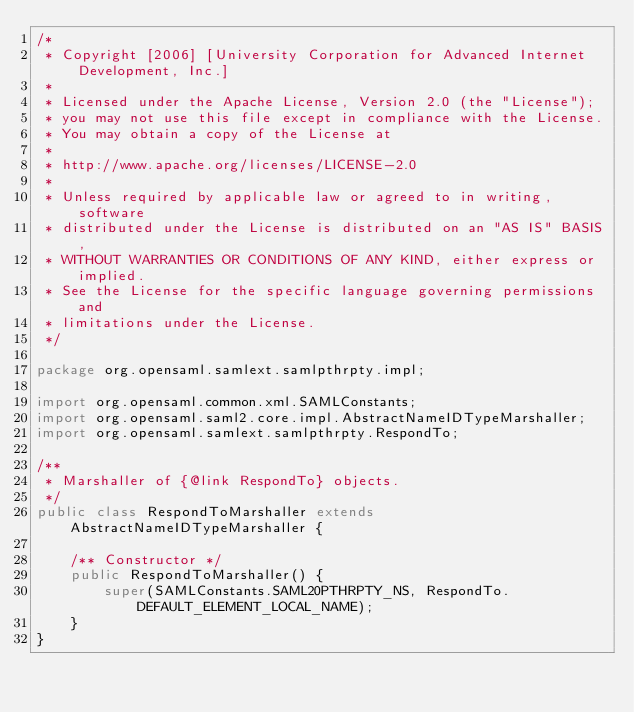Convert code to text. <code><loc_0><loc_0><loc_500><loc_500><_Java_>/*
 * Copyright [2006] [University Corporation for Advanced Internet Development, Inc.]
 *
 * Licensed under the Apache License, Version 2.0 (the "License");
 * you may not use this file except in compliance with the License.
 * You may obtain a copy of the License at
 *
 * http://www.apache.org/licenses/LICENSE-2.0
 *
 * Unless required by applicable law or agreed to in writing, software
 * distributed under the License is distributed on an "AS IS" BASIS,
 * WITHOUT WARRANTIES OR CONDITIONS OF ANY KIND, either express or implied.
 * See the License for the specific language governing permissions and
 * limitations under the License.
 */

package org.opensaml.samlext.samlpthrpty.impl;

import org.opensaml.common.xml.SAMLConstants;
import org.opensaml.saml2.core.impl.AbstractNameIDTypeMarshaller;
import org.opensaml.samlext.samlpthrpty.RespondTo;

/**
 * Marshaller of {@link RespondTo} objects.
 */
public class RespondToMarshaller extends AbstractNameIDTypeMarshaller {

    /** Constructor */
    public RespondToMarshaller() {
        super(SAMLConstants.SAML20PTHRPTY_NS, RespondTo.DEFAULT_ELEMENT_LOCAL_NAME);
    }
}</code> 